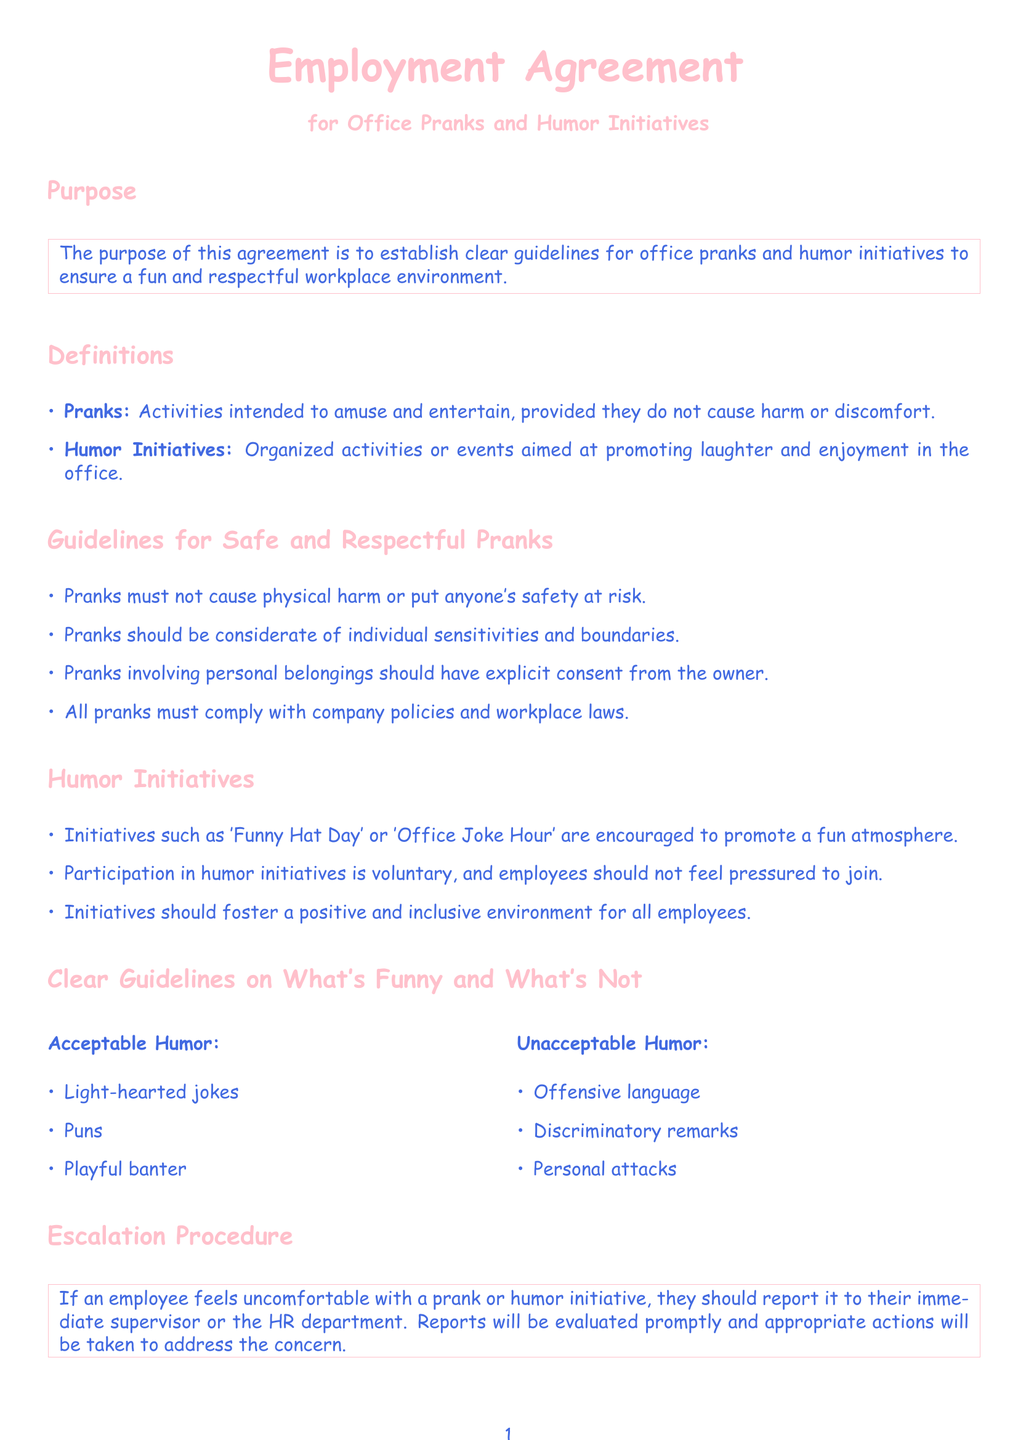What is the purpose of the agreement? The purpose of the agreement is outlined in the document, stating it is to establish clear guidelines for office pranks and humor initiatives to ensure a fun and respectful workplace environment.
Answer: To establish clear guidelines for office pranks and humor initiatives What are the acceptable types of humor listed? The document lists acceptable humor in a column, specifically light-hearted jokes, puns, and playful banter.
Answer: Light-hearted jokes, puns, playful banter Who should employees report to if there's an issue with a prank? The escalation procedure section indicates that employees should report to their immediate supervisor or the HR department if they feel uncomfortable.
Answer: Their immediate supervisor or the HR department What is explicitly required before a prank involves personal belongings? The guidelines specify that pranks involving personal belongings should have explicit consent from the owner.
Answer: Explicit consent from the owner Name one example of a humor initiative mentioned. The humor initiatives section provides examples like 'Funny Hat Day' or 'Office Joke Hour,' which promote a fun atmosphere.
Answer: 'Funny Hat Day' What must pranks comply with according to the guidelines? The guidelines state that all pranks must comply with company policies and workplace laws.
Answer: Company policies and workplace laws What type of humor is considered unacceptable? Unacceptable humor types are outlined, including offensive language, discriminatory remarks, and personal attacks.
Answer: Offensive language, discriminatory remarks, personal attacks How are reports evaluated regarding uncomfortable pranks? The escalation procedure states that reports will be evaluated promptly and appropriate actions will be taken to address the concern.
Answer: Evaluated promptly What section outlines the acknowledgment of the agreement? The acknowledgment portion of the agreement details that employees must sign to confirm they have read and understood the guidelines.
Answer: Acknowledgment section 